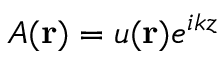Convert formula to latex. <formula><loc_0><loc_0><loc_500><loc_500>A ( r ) = u ( r ) e ^ { i k z }</formula> 